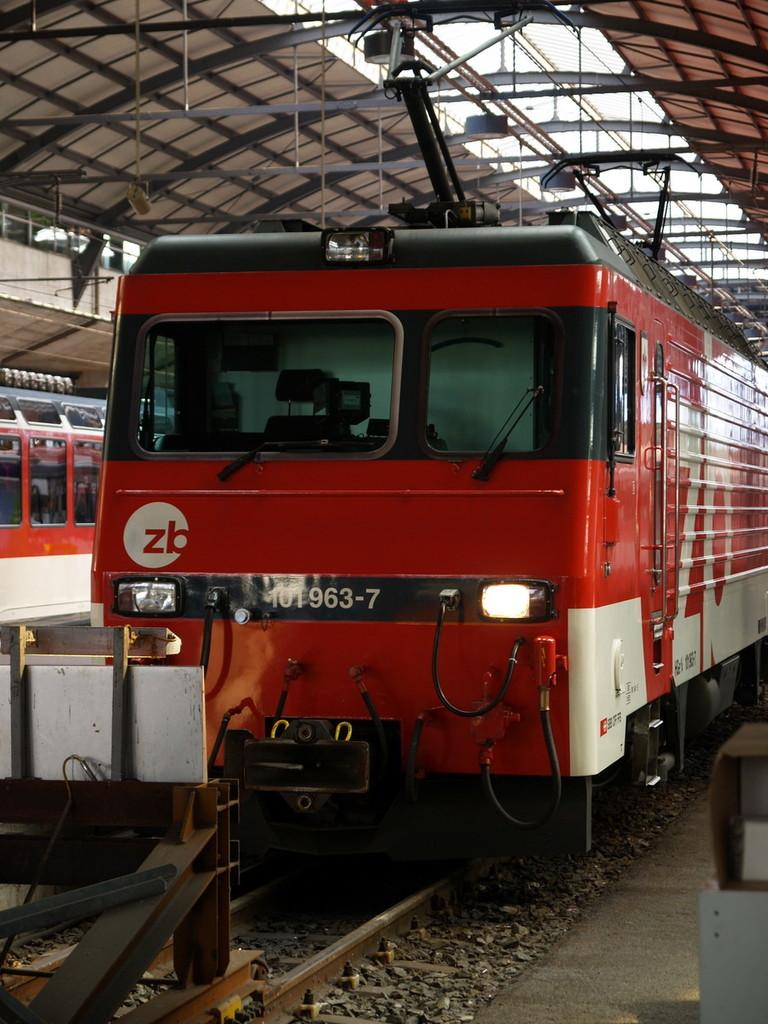What is the main subject of the image? The main subject of the image is a train. Where is the train located in the image? The train is on a railway track. What can be seen near the railway track? There are stones near the railway track. What else is visible in the image besides the train and stones? There are rods visible in the image. Is there any text or writing on the train? Yes, there is text or writing on the train. How many beggars are standing near the train in the image? There are no beggars present in the image; it only features a train, railway track, stones, rods, and text or writing on the train. What type of shoes can be seen on the beggar in the image? There is no beggar or shoes present in the image. 